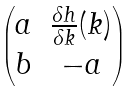<formula> <loc_0><loc_0><loc_500><loc_500>\begin{pmatrix} a & \frac { \delta h } { \delta k } ( k ) \\ b & - a \end{pmatrix}</formula> 